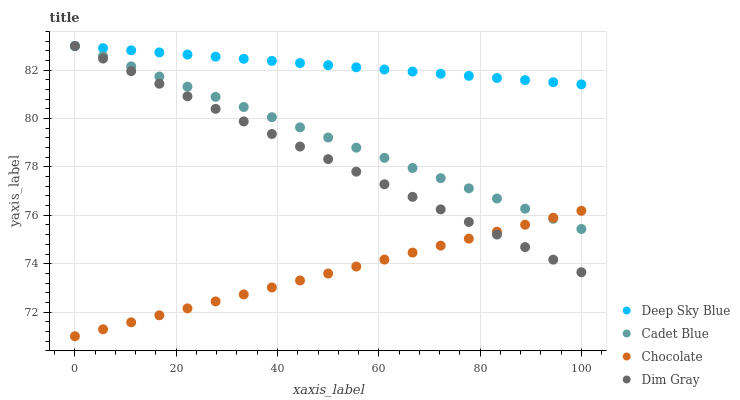Does Chocolate have the minimum area under the curve?
Answer yes or no. Yes. Does Deep Sky Blue have the maximum area under the curve?
Answer yes or no. Yes. Does Cadet Blue have the minimum area under the curve?
Answer yes or no. No. Does Cadet Blue have the maximum area under the curve?
Answer yes or no. No. Is Chocolate the smoothest?
Answer yes or no. Yes. Is Dim Gray the roughest?
Answer yes or no. Yes. Is Cadet Blue the smoothest?
Answer yes or no. No. Is Cadet Blue the roughest?
Answer yes or no. No. Does Chocolate have the lowest value?
Answer yes or no. Yes. Does Cadet Blue have the lowest value?
Answer yes or no. No. Does Deep Sky Blue have the highest value?
Answer yes or no. Yes. Does Chocolate have the highest value?
Answer yes or no. No. Is Chocolate less than Deep Sky Blue?
Answer yes or no. Yes. Is Deep Sky Blue greater than Chocolate?
Answer yes or no. Yes. Does Cadet Blue intersect Chocolate?
Answer yes or no. Yes. Is Cadet Blue less than Chocolate?
Answer yes or no. No. Is Cadet Blue greater than Chocolate?
Answer yes or no. No. Does Chocolate intersect Deep Sky Blue?
Answer yes or no. No. 